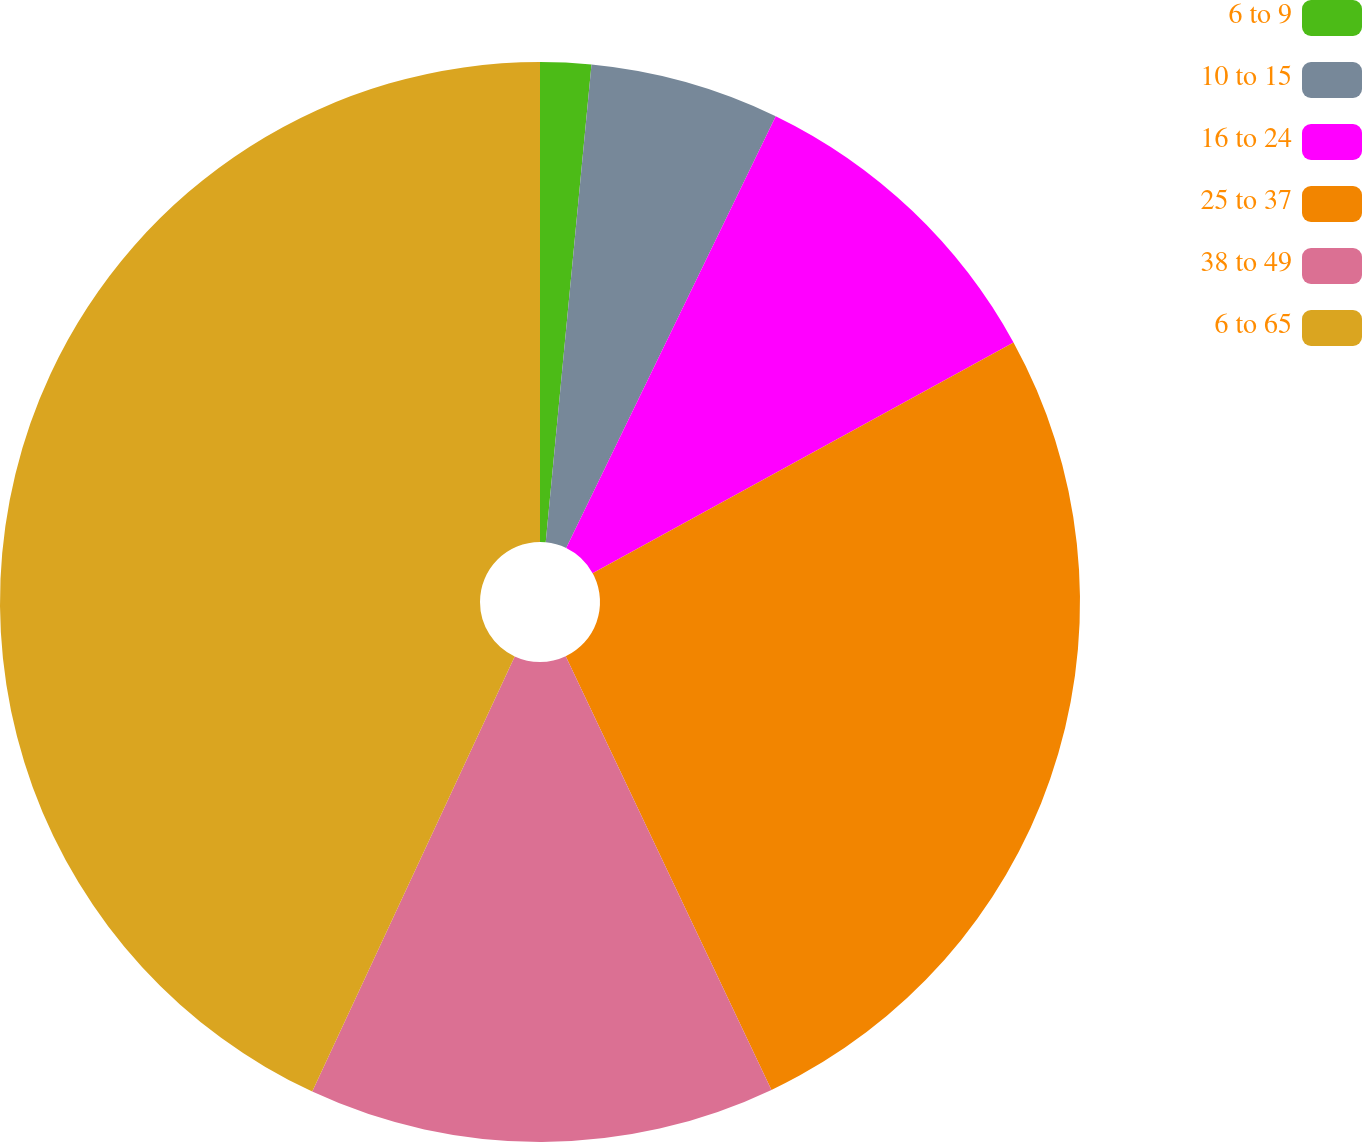Convert chart. <chart><loc_0><loc_0><loc_500><loc_500><pie_chart><fcel>6 to 9<fcel>10 to 15<fcel>16 to 24<fcel>25 to 37<fcel>38 to 49<fcel>6 to 65<nl><fcel>1.52%<fcel>5.67%<fcel>9.83%<fcel>25.93%<fcel>13.98%<fcel>43.07%<nl></chart> 